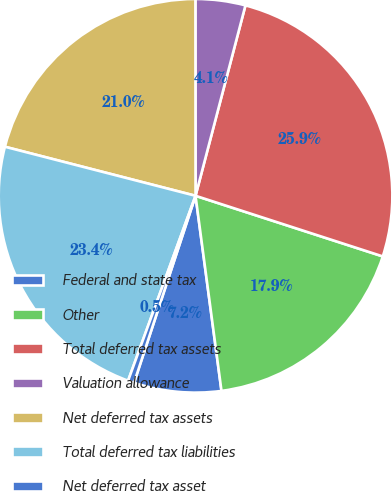Convert chart. <chart><loc_0><loc_0><loc_500><loc_500><pie_chart><fcel>Federal and state tax<fcel>Other<fcel>Total deferred tax assets<fcel>Valuation allowance<fcel>Net deferred tax assets<fcel>Total deferred tax liabilities<fcel>Net deferred tax asset<nl><fcel>7.16%<fcel>17.91%<fcel>25.9%<fcel>4.09%<fcel>20.98%<fcel>23.44%<fcel>0.51%<nl></chart> 